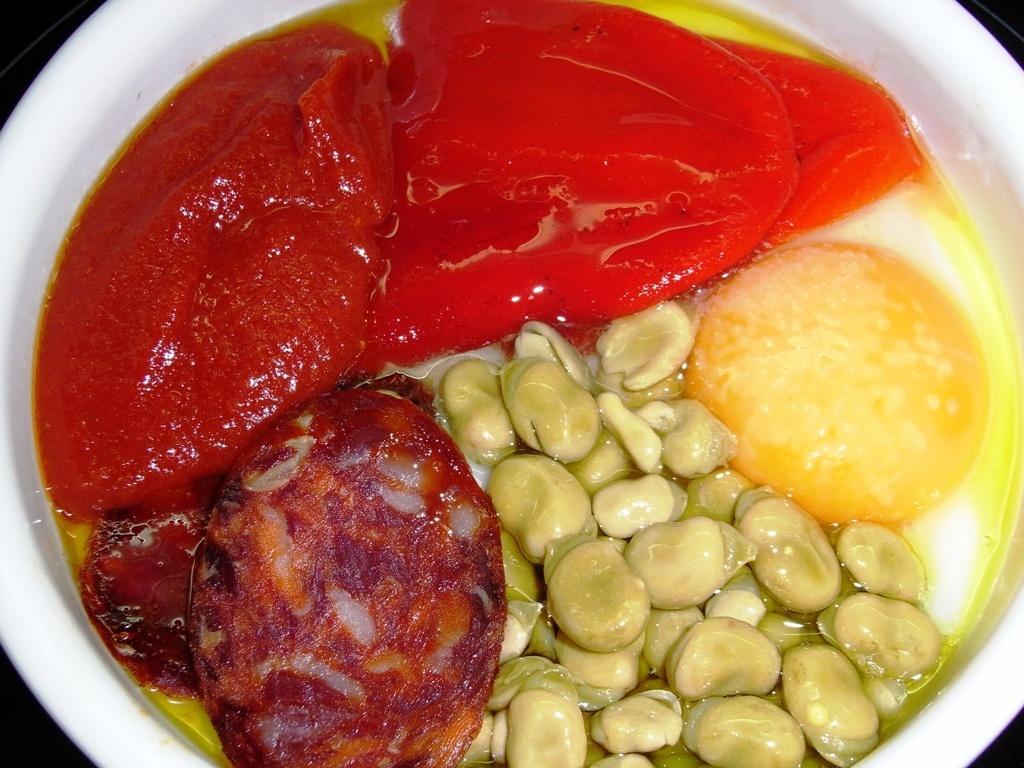Could you give a brief overview of what you see in this image? In this image there are some food items are kept in white colored bowl. 